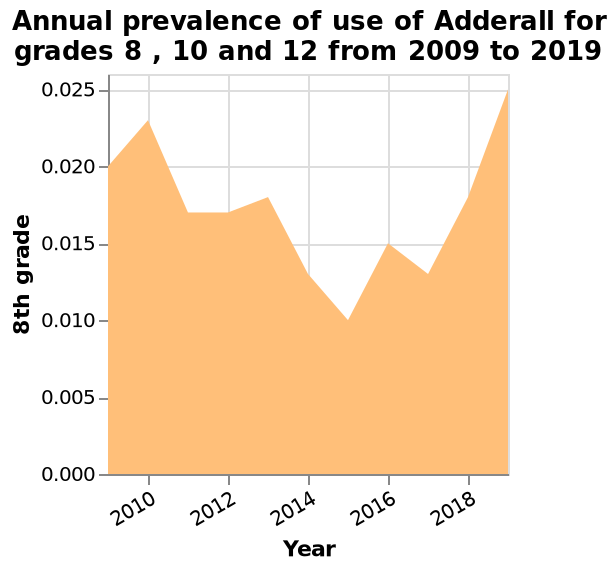<image>
What are the grade levels included in the annual prevalence data for Adderall use? The grade levels included in the annual prevalence data for Adderall use are 8th, 10th, and 12th grades. Was there an increase or decrease in the use of Adderall for grade 8 between 2015 and 2019? There was an increase in the use of Adderall for grade 8 between 2015 and 2019. please describe the details of the chart Annual prevalence of use of Adderall for grades 8 , 10 and 12 from 2009 to 2019 is a area diagram. There is a linear scale from 0.000 to 0.025 on the y-axis, labeled 8th grade. Year is shown with a linear scale from 2010 to 2018 on the x-axis. In which year did grade 8 have the highest usage of Adderall? The year with the greatest use of Adderall for grade 8 was 2019. What is the highest prevalence of Adderall use shown in the area diagram? The highest prevalence of Adderall use shown in the area diagram is not provided in the given information. Is the highest prevalence of Adderall use shown in the area diagram provided in the given information? No.The highest prevalence of Adderall use shown in the area diagram is not provided in the given information. 